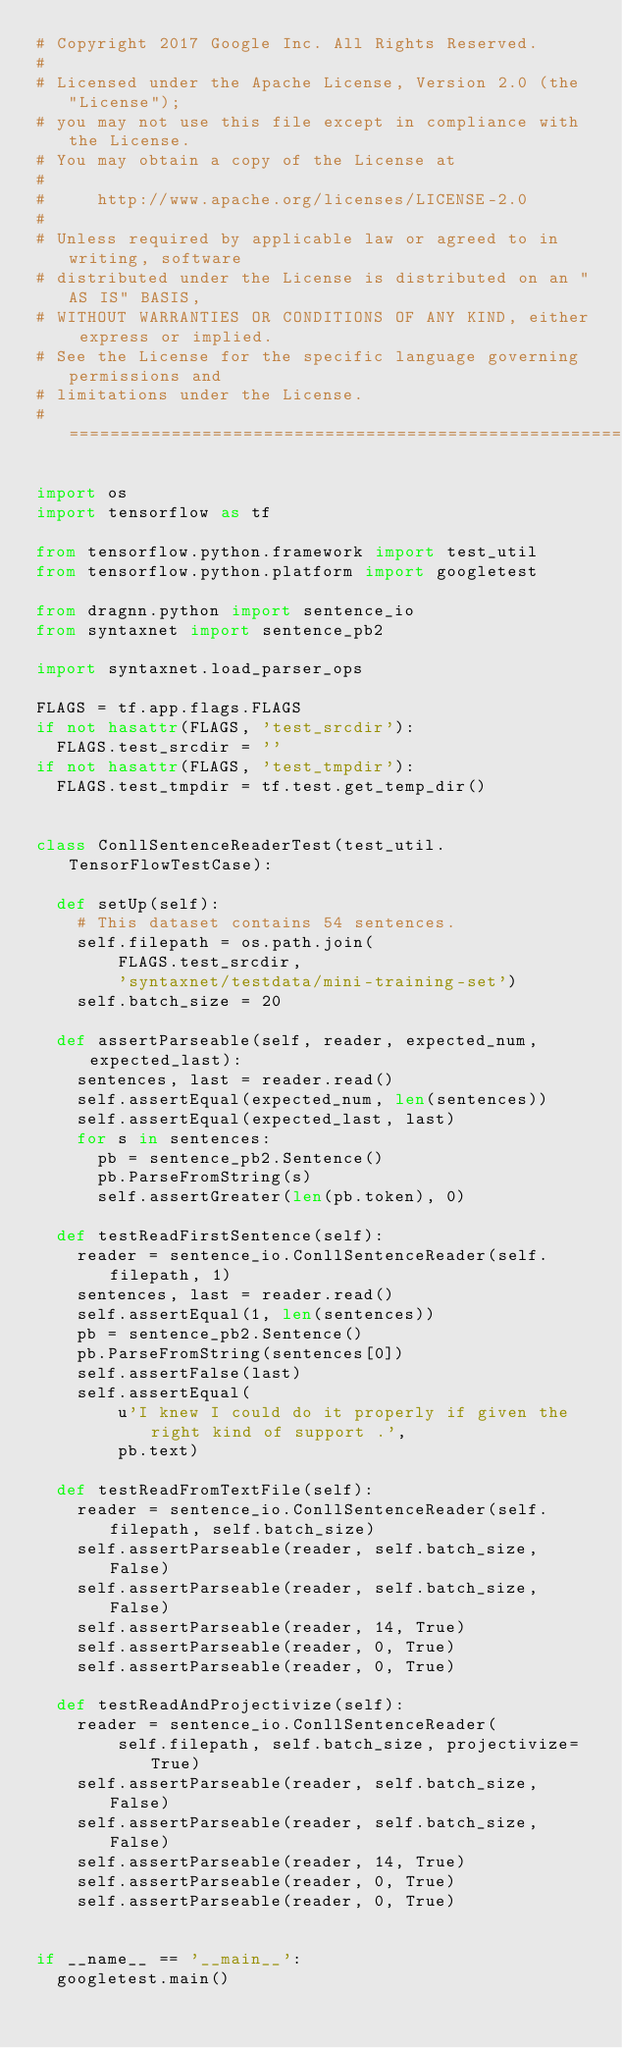<code> <loc_0><loc_0><loc_500><loc_500><_Python_># Copyright 2017 Google Inc. All Rights Reserved.
#
# Licensed under the Apache License, Version 2.0 (the "License");
# you may not use this file except in compliance with the License.
# You may obtain a copy of the License at
#
#     http://www.apache.org/licenses/LICENSE-2.0
#
# Unless required by applicable law or agreed to in writing, software
# distributed under the License is distributed on an "AS IS" BASIS,
# WITHOUT WARRANTIES OR CONDITIONS OF ANY KIND, either express or implied.
# See the License for the specific language governing permissions and
# limitations under the License.
# ==============================================================================

import os
import tensorflow as tf

from tensorflow.python.framework import test_util
from tensorflow.python.platform import googletest

from dragnn.python import sentence_io
from syntaxnet import sentence_pb2

import syntaxnet.load_parser_ops

FLAGS = tf.app.flags.FLAGS
if not hasattr(FLAGS, 'test_srcdir'):
  FLAGS.test_srcdir = ''
if not hasattr(FLAGS, 'test_tmpdir'):
  FLAGS.test_tmpdir = tf.test.get_temp_dir()


class ConllSentenceReaderTest(test_util.TensorFlowTestCase):

  def setUp(self):
    # This dataset contains 54 sentences.
    self.filepath = os.path.join(
        FLAGS.test_srcdir,
        'syntaxnet/testdata/mini-training-set')
    self.batch_size = 20

  def assertParseable(self, reader, expected_num, expected_last):
    sentences, last = reader.read()
    self.assertEqual(expected_num, len(sentences))
    self.assertEqual(expected_last, last)
    for s in sentences:
      pb = sentence_pb2.Sentence()
      pb.ParseFromString(s)
      self.assertGreater(len(pb.token), 0)

  def testReadFirstSentence(self):
    reader = sentence_io.ConllSentenceReader(self.filepath, 1)
    sentences, last = reader.read()
    self.assertEqual(1, len(sentences))
    pb = sentence_pb2.Sentence()
    pb.ParseFromString(sentences[0])
    self.assertFalse(last)
    self.assertEqual(
        u'I knew I could do it properly if given the right kind of support .',
        pb.text)

  def testReadFromTextFile(self):
    reader = sentence_io.ConllSentenceReader(self.filepath, self.batch_size)
    self.assertParseable(reader, self.batch_size, False)
    self.assertParseable(reader, self.batch_size, False)
    self.assertParseable(reader, 14, True)
    self.assertParseable(reader, 0, True)
    self.assertParseable(reader, 0, True)

  def testReadAndProjectivize(self):
    reader = sentence_io.ConllSentenceReader(
        self.filepath, self.batch_size, projectivize=True)
    self.assertParseable(reader, self.batch_size, False)
    self.assertParseable(reader, self.batch_size, False)
    self.assertParseable(reader, 14, True)
    self.assertParseable(reader, 0, True)
    self.assertParseable(reader, 0, True)


if __name__ == '__main__':
  googletest.main()
</code> 